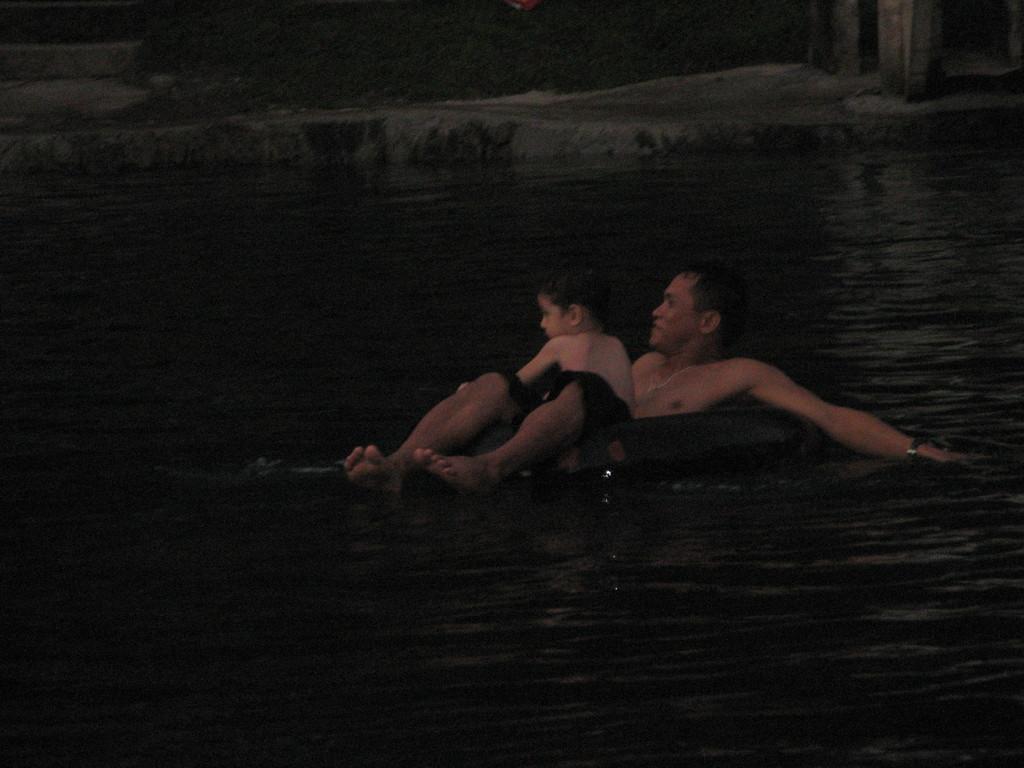Describe this image in one or two sentences. In this image we can see a boy on a person sitting in a swimming tube placed on the water. 